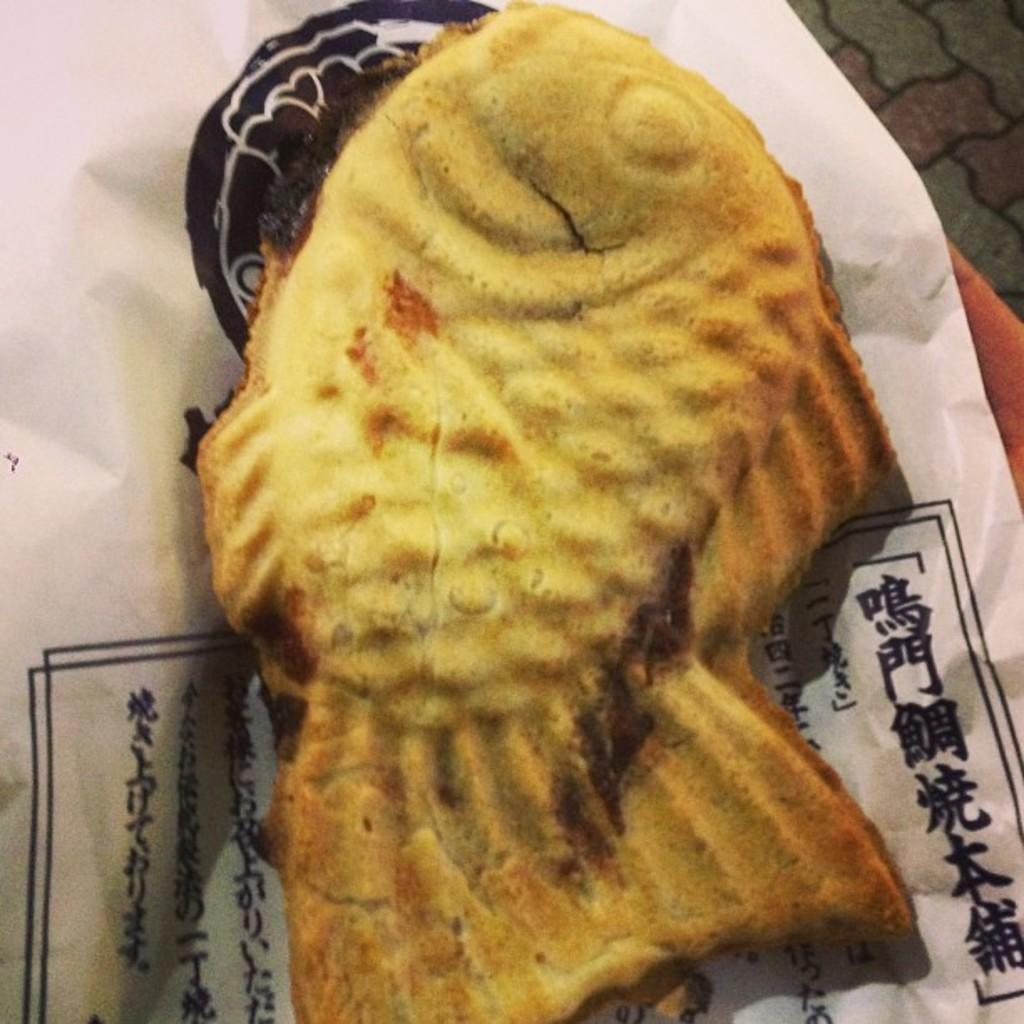What type of food can be seen in the image? There are snacks in the image. How are the snacks presented? The snacks are on a paper. Can you see a stream flowing through the snacks in the image? There is no stream present in the image; it only features snacks on a paper. 